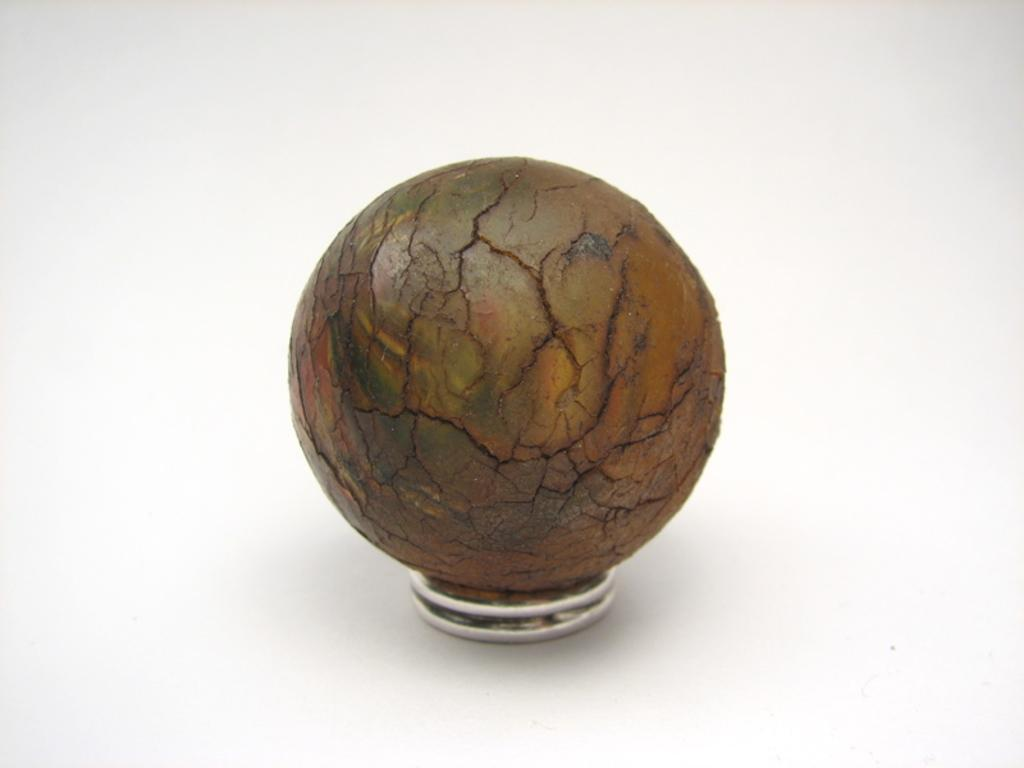How many coins are visible in the image? There are two coins in the image. What is the appearance of the object on the coins? The object on the coins has a brown and green color and is circular in shape. What is the color of the background in the image? The background is white in color. What type of education can be seen on the monkey in the image? There is no monkey present in the image, and therefore no education can be observed. What is the stem used for in the image? There is no stem present in the image. 